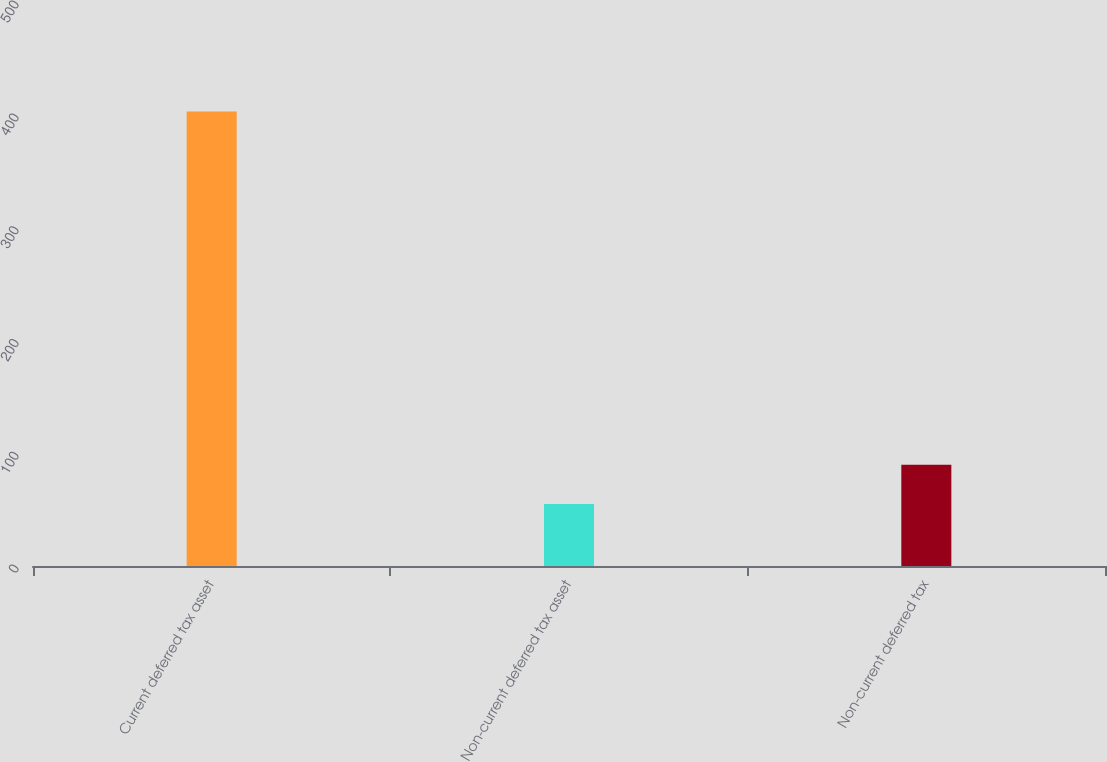<chart> <loc_0><loc_0><loc_500><loc_500><bar_chart><fcel>Current deferred tax asset<fcel>Non-current deferred tax asset<fcel>Non-current deferred tax<nl><fcel>403<fcel>55<fcel>89.8<nl></chart> 